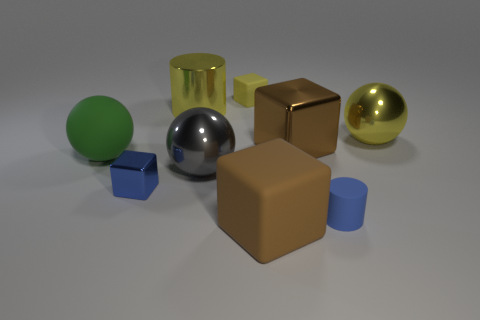What shape is the big thing that is the same color as the shiny cylinder?
Keep it short and to the point. Sphere. There is a matte object that is the same color as the big shiny cube; what is its size?
Ensure brevity in your answer.  Large. What number of other objects are there of the same shape as the brown matte object?
Ensure brevity in your answer.  3. Are there any cubes that are in front of the small cylinder in front of the small shiny object?
Offer a very short reply. Yes. What number of large balls are there?
Make the answer very short. 3. There is a matte cylinder; does it have the same color as the small block that is to the left of the small yellow matte block?
Ensure brevity in your answer.  Yes. Are there more big metal things than large blocks?
Keep it short and to the point. Yes. Are there any other things that have the same color as the matte ball?
Provide a succinct answer. No. What number of other objects are the same size as the yellow metallic ball?
Your response must be concise. 5. There is a big block that is behind the large matte thing that is to the right of the rubber thing behind the rubber ball; what is it made of?
Your answer should be very brief. Metal. 